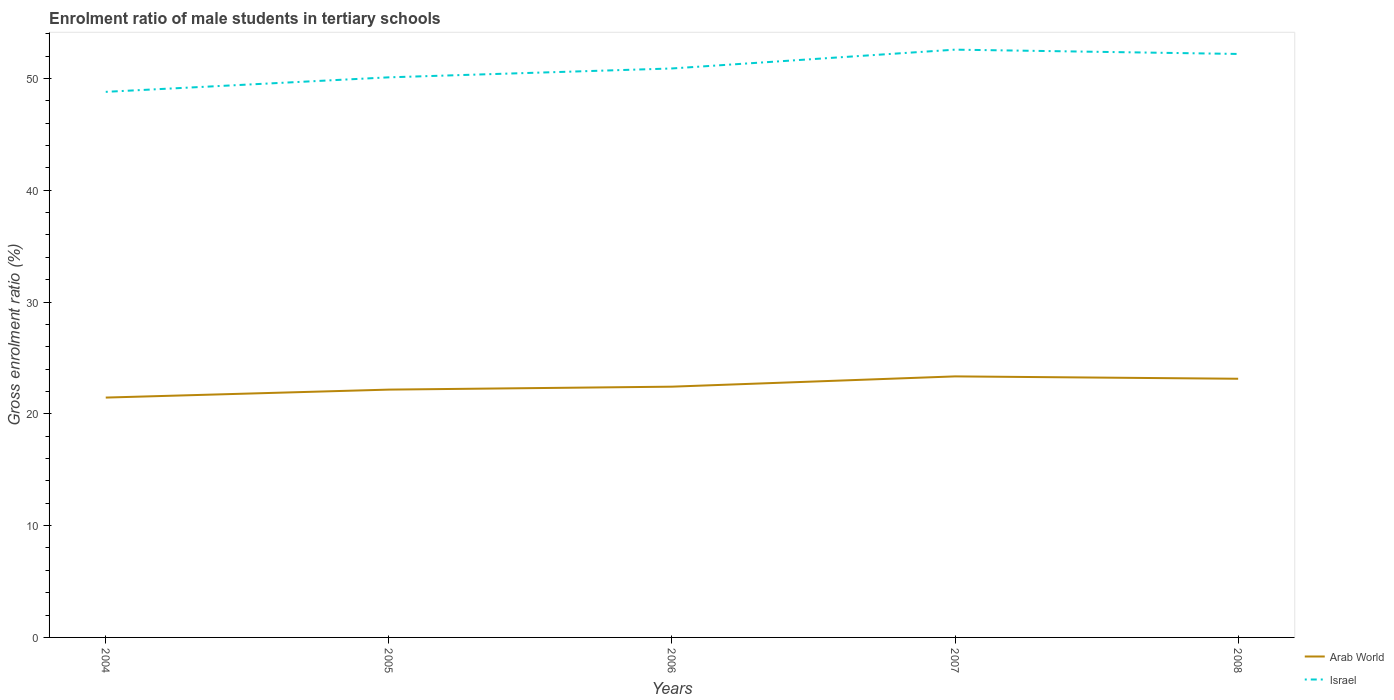Does the line corresponding to Arab World intersect with the line corresponding to Israel?
Offer a terse response. No. Is the number of lines equal to the number of legend labels?
Make the answer very short. Yes. Across all years, what is the maximum enrolment ratio of male students in tertiary schools in Israel?
Offer a very short reply. 48.8. What is the total enrolment ratio of male students in tertiary schools in Arab World in the graph?
Give a very brief answer. -1.18. What is the difference between the highest and the second highest enrolment ratio of male students in tertiary schools in Israel?
Give a very brief answer. 3.77. How many lines are there?
Your answer should be compact. 2. How many years are there in the graph?
Provide a succinct answer. 5. Does the graph contain grids?
Make the answer very short. No. Where does the legend appear in the graph?
Your response must be concise. Bottom right. What is the title of the graph?
Keep it short and to the point. Enrolment ratio of male students in tertiary schools. Does "Burkina Faso" appear as one of the legend labels in the graph?
Your answer should be compact. No. What is the label or title of the Y-axis?
Keep it short and to the point. Gross enrolment ratio (%). What is the Gross enrolment ratio (%) of Arab World in 2004?
Offer a terse response. 21.45. What is the Gross enrolment ratio (%) of Israel in 2004?
Your response must be concise. 48.8. What is the Gross enrolment ratio (%) in Arab World in 2005?
Provide a short and direct response. 22.17. What is the Gross enrolment ratio (%) of Israel in 2005?
Offer a very short reply. 50.1. What is the Gross enrolment ratio (%) of Arab World in 2006?
Give a very brief answer. 22.43. What is the Gross enrolment ratio (%) of Israel in 2006?
Keep it short and to the point. 50.89. What is the Gross enrolment ratio (%) in Arab World in 2007?
Your answer should be very brief. 23.35. What is the Gross enrolment ratio (%) in Israel in 2007?
Ensure brevity in your answer.  52.57. What is the Gross enrolment ratio (%) in Arab World in 2008?
Your answer should be compact. 23.14. What is the Gross enrolment ratio (%) of Israel in 2008?
Make the answer very short. 52.19. Across all years, what is the maximum Gross enrolment ratio (%) of Arab World?
Provide a short and direct response. 23.35. Across all years, what is the maximum Gross enrolment ratio (%) of Israel?
Offer a terse response. 52.57. Across all years, what is the minimum Gross enrolment ratio (%) of Arab World?
Your answer should be compact. 21.45. Across all years, what is the minimum Gross enrolment ratio (%) of Israel?
Ensure brevity in your answer.  48.8. What is the total Gross enrolment ratio (%) in Arab World in the graph?
Provide a succinct answer. 112.53. What is the total Gross enrolment ratio (%) of Israel in the graph?
Your answer should be compact. 254.55. What is the difference between the Gross enrolment ratio (%) of Arab World in 2004 and that in 2005?
Your response must be concise. -0.71. What is the difference between the Gross enrolment ratio (%) of Israel in 2004 and that in 2005?
Give a very brief answer. -1.3. What is the difference between the Gross enrolment ratio (%) of Arab World in 2004 and that in 2006?
Your response must be concise. -0.98. What is the difference between the Gross enrolment ratio (%) of Israel in 2004 and that in 2006?
Your answer should be very brief. -2.09. What is the difference between the Gross enrolment ratio (%) of Arab World in 2004 and that in 2007?
Offer a very short reply. -1.9. What is the difference between the Gross enrolment ratio (%) of Israel in 2004 and that in 2007?
Make the answer very short. -3.77. What is the difference between the Gross enrolment ratio (%) in Arab World in 2004 and that in 2008?
Your response must be concise. -1.68. What is the difference between the Gross enrolment ratio (%) of Israel in 2004 and that in 2008?
Provide a short and direct response. -3.39. What is the difference between the Gross enrolment ratio (%) of Arab World in 2005 and that in 2006?
Offer a terse response. -0.26. What is the difference between the Gross enrolment ratio (%) of Israel in 2005 and that in 2006?
Offer a very short reply. -0.79. What is the difference between the Gross enrolment ratio (%) in Arab World in 2005 and that in 2007?
Keep it short and to the point. -1.18. What is the difference between the Gross enrolment ratio (%) in Israel in 2005 and that in 2007?
Ensure brevity in your answer.  -2.48. What is the difference between the Gross enrolment ratio (%) in Arab World in 2005 and that in 2008?
Keep it short and to the point. -0.97. What is the difference between the Gross enrolment ratio (%) in Israel in 2005 and that in 2008?
Offer a terse response. -2.09. What is the difference between the Gross enrolment ratio (%) in Arab World in 2006 and that in 2007?
Your answer should be very brief. -0.92. What is the difference between the Gross enrolment ratio (%) in Israel in 2006 and that in 2007?
Your answer should be very brief. -1.68. What is the difference between the Gross enrolment ratio (%) in Arab World in 2006 and that in 2008?
Your answer should be compact. -0.71. What is the difference between the Gross enrolment ratio (%) in Israel in 2006 and that in 2008?
Keep it short and to the point. -1.3. What is the difference between the Gross enrolment ratio (%) in Arab World in 2007 and that in 2008?
Provide a short and direct response. 0.21. What is the difference between the Gross enrolment ratio (%) in Israel in 2007 and that in 2008?
Offer a terse response. 0.39. What is the difference between the Gross enrolment ratio (%) in Arab World in 2004 and the Gross enrolment ratio (%) in Israel in 2005?
Your answer should be compact. -28.64. What is the difference between the Gross enrolment ratio (%) in Arab World in 2004 and the Gross enrolment ratio (%) in Israel in 2006?
Your answer should be compact. -29.44. What is the difference between the Gross enrolment ratio (%) of Arab World in 2004 and the Gross enrolment ratio (%) of Israel in 2007?
Keep it short and to the point. -31.12. What is the difference between the Gross enrolment ratio (%) in Arab World in 2004 and the Gross enrolment ratio (%) in Israel in 2008?
Give a very brief answer. -30.73. What is the difference between the Gross enrolment ratio (%) in Arab World in 2005 and the Gross enrolment ratio (%) in Israel in 2006?
Your response must be concise. -28.73. What is the difference between the Gross enrolment ratio (%) in Arab World in 2005 and the Gross enrolment ratio (%) in Israel in 2007?
Your response must be concise. -30.41. What is the difference between the Gross enrolment ratio (%) in Arab World in 2005 and the Gross enrolment ratio (%) in Israel in 2008?
Ensure brevity in your answer.  -30.02. What is the difference between the Gross enrolment ratio (%) of Arab World in 2006 and the Gross enrolment ratio (%) of Israel in 2007?
Provide a short and direct response. -30.15. What is the difference between the Gross enrolment ratio (%) of Arab World in 2006 and the Gross enrolment ratio (%) of Israel in 2008?
Your answer should be very brief. -29.76. What is the difference between the Gross enrolment ratio (%) in Arab World in 2007 and the Gross enrolment ratio (%) in Israel in 2008?
Your answer should be compact. -28.84. What is the average Gross enrolment ratio (%) in Arab World per year?
Keep it short and to the point. 22.51. What is the average Gross enrolment ratio (%) of Israel per year?
Provide a short and direct response. 50.91. In the year 2004, what is the difference between the Gross enrolment ratio (%) in Arab World and Gross enrolment ratio (%) in Israel?
Offer a very short reply. -27.35. In the year 2005, what is the difference between the Gross enrolment ratio (%) in Arab World and Gross enrolment ratio (%) in Israel?
Provide a succinct answer. -27.93. In the year 2006, what is the difference between the Gross enrolment ratio (%) of Arab World and Gross enrolment ratio (%) of Israel?
Provide a short and direct response. -28.46. In the year 2007, what is the difference between the Gross enrolment ratio (%) in Arab World and Gross enrolment ratio (%) in Israel?
Your answer should be very brief. -29.23. In the year 2008, what is the difference between the Gross enrolment ratio (%) in Arab World and Gross enrolment ratio (%) in Israel?
Offer a very short reply. -29.05. What is the ratio of the Gross enrolment ratio (%) of Arab World in 2004 to that in 2005?
Your answer should be very brief. 0.97. What is the ratio of the Gross enrolment ratio (%) in Israel in 2004 to that in 2005?
Your answer should be compact. 0.97. What is the ratio of the Gross enrolment ratio (%) in Arab World in 2004 to that in 2006?
Offer a very short reply. 0.96. What is the ratio of the Gross enrolment ratio (%) of Israel in 2004 to that in 2006?
Offer a very short reply. 0.96. What is the ratio of the Gross enrolment ratio (%) of Arab World in 2004 to that in 2007?
Your response must be concise. 0.92. What is the ratio of the Gross enrolment ratio (%) of Israel in 2004 to that in 2007?
Ensure brevity in your answer.  0.93. What is the ratio of the Gross enrolment ratio (%) of Arab World in 2004 to that in 2008?
Provide a short and direct response. 0.93. What is the ratio of the Gross enrolment ratio (%) of Israel in 2004 to that in 2008?
Your answer should be compact. 0.94. What is the ratio of the Gross enrolment ratio (%) in Arab World in 2005 to that in 2006?
Provide a short and direct response. 0.99. What is the ratio of the Gross enrolment ratio (%) of Israel in 2005 to that in 2006?
Your response must be concise. 0.98. What is the ratio of the Gross enrolment ratio (%) in Arab World in 2005 to that in 2007?
Your answer should be compact. 0.95. What is the ratio of the Gross enrolment ratio (%) in Israel in 2005 to that in 2007?
Offer a terse response. 0.95. What is the ratio of the Gross enrolment ratio (%) in Arab World in 2005 to that in 2008?
Offer a terse response. 0.96. What is the ratio of the Gross enrolment ratio (%) in Israel in 2005 to that in 2008?
Provide a succinct answer. 0.96. What is the ratio of the Gross enrolment ratio (%) in Arab World in 2006 to that in 2007?
Your answer should be very brief. 0.96. What is the ratio of the Gross enrolment ratio (%) of Arab World in 2006 to that in 2008?
Give a very brief answer. 0.97. What is the ratio of the Gross enrolment ratio (%) in Israel in 2006 to that in 2008?
Your answer should be very brief. 0.98. What is the ratio of the Gross enrolment ratio (%) in Arab World in 2007 to that in 2008?
Offer a terse response. 1.01. What is the ratio of the Gross enrolment ratio (%) of Israel in 2007 to that in 2008?
Make the answer very short. 1.01. What is the difference between the highest and the second highest Gross enrolment ratio (%) of Arab World?
Offer a terse response. 0.21. What is the difference between the highest and the second highest Gross enrolment ratio (%) in Israel?
Your response must be concise. 0.39. What is the difference between the highest and the lowest Gross enrolment ratio (%) in Arab World?
Provide a succinct answer. 1.9. What is the difference between the highest and the lowest Gross enrolment ratio (%) in Israel?
Offer a terse response. 3.77. 